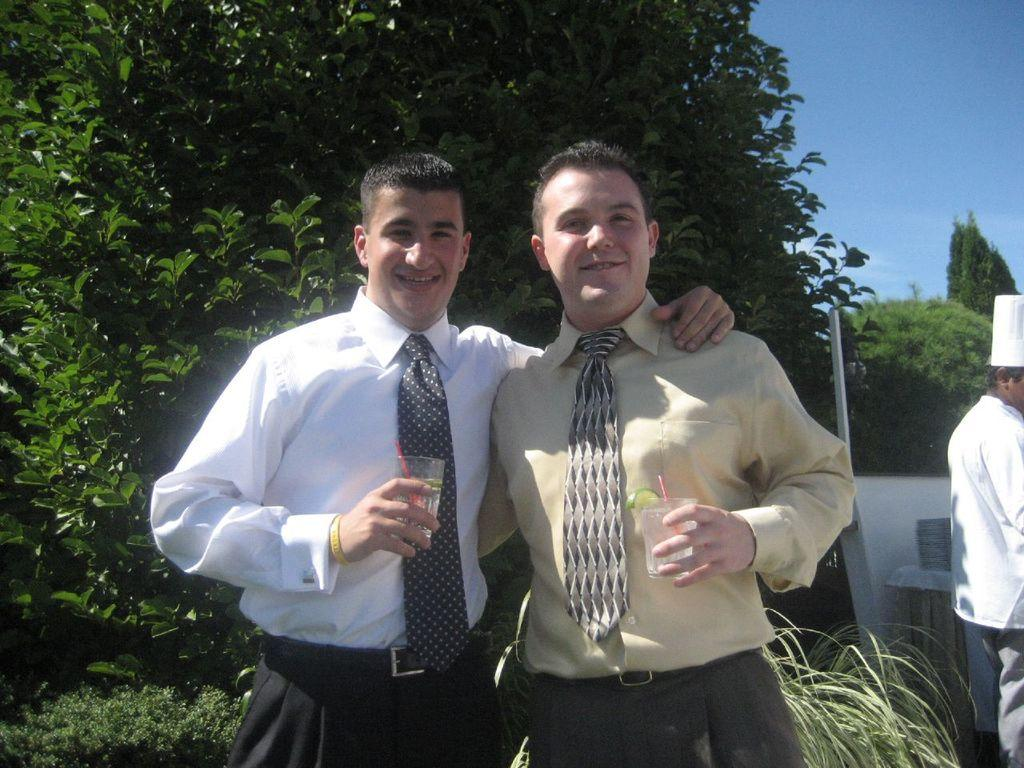How many people are in the image? There are two people standing in the image. What are the two people doing? The two people are posing for a photo. Where is the chef located in the image? The chef is on the right side of the image. What can be seen in the background of the image? There are many trees in the background of the image. How many dolls are visible in the image? There are no dolls present in the image. What type of crowd can be seen in the background of the image? There is no crowd visible in the image; only trees are present in the background. 